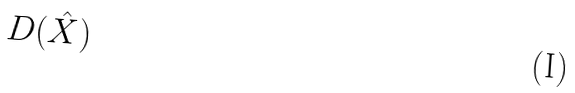Convert formula to latex. <formula><loc_0><loc_0><loc_500><loc_500>D ( \hat { X } )</formula> 